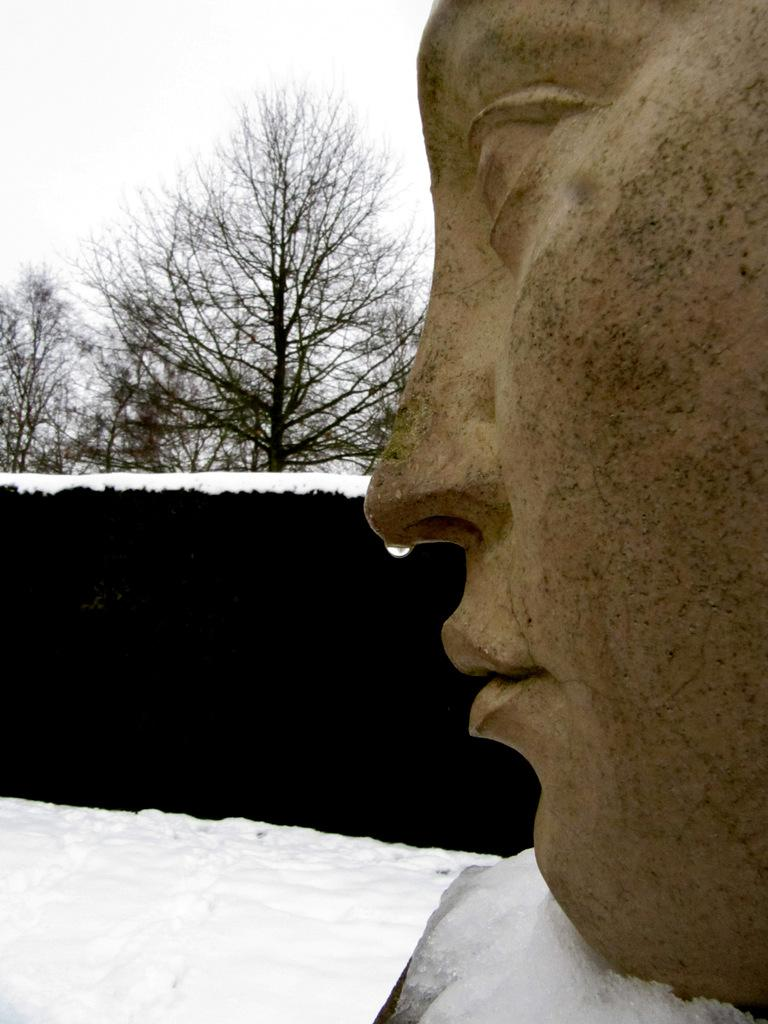What is the main subject of the image? There is a sculpture in the image. What can be seen on the left side of the image? There is snow on the left side of the image. What type of natural elements are visible in the background of the image? There are trees in the background of the image. What is visible at the top of the image? The sky is visible at the top of the image. What is the name of the son of the sculpture in the image? There is no son of the sculpture present in the image, as it is an inanimate object. How many icicles can be seen hanging from the trees in the image? There is no mention of icicles in the image; only snow is mentioned on the left side. 